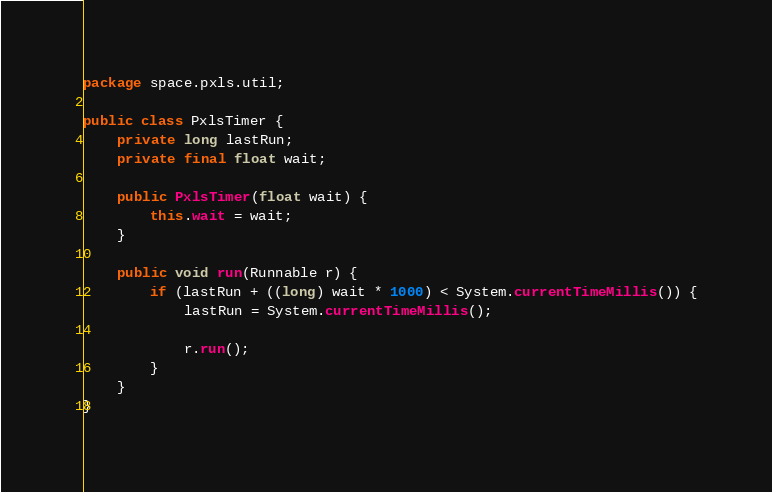<code> <loc_0><loc_0><loc_500><loc_500><_Java_>package space.pxls.util;

public class PxlsTimer {
    private long lastRun;
    private final float wait;

    public PxlsTimer(float wait) {
        this.wait = wait;
    }

    public void run(Runnable r) {
        if (lastRun + ((long) wait * 1000) < System.currentTimeMillis()) {
            lastRun = System.currentTimeMillis();

            r.run();
        }
    }
}
</code> 